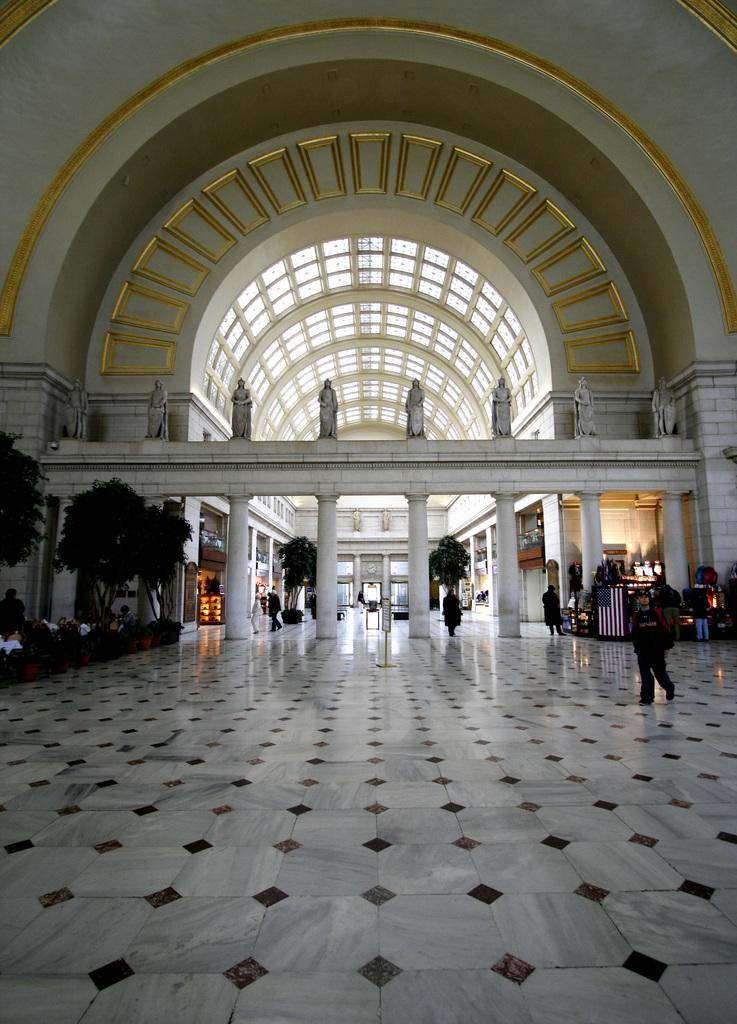What type of space is depicted in the image? The image is of an architectural building's interior. What kind of artwork can be seen in the building? There are sculptures in the building. What unusual feature is present inside the building? There are trees inside the building. What are the people in the image doing? There is a group of people sitting in the building, and there are people walking inside the building. What type of wax can be seen melting in the garden outside the building? There is no wax or garden present in the image; it depicts the interior of a building with trees and people. 